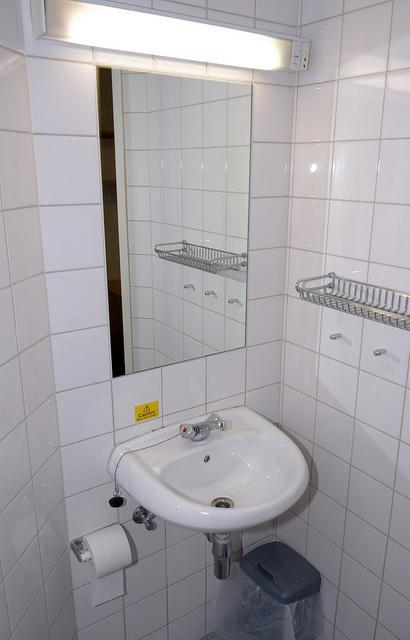How many people with hat are there?
Give a very brief answer. 0. 